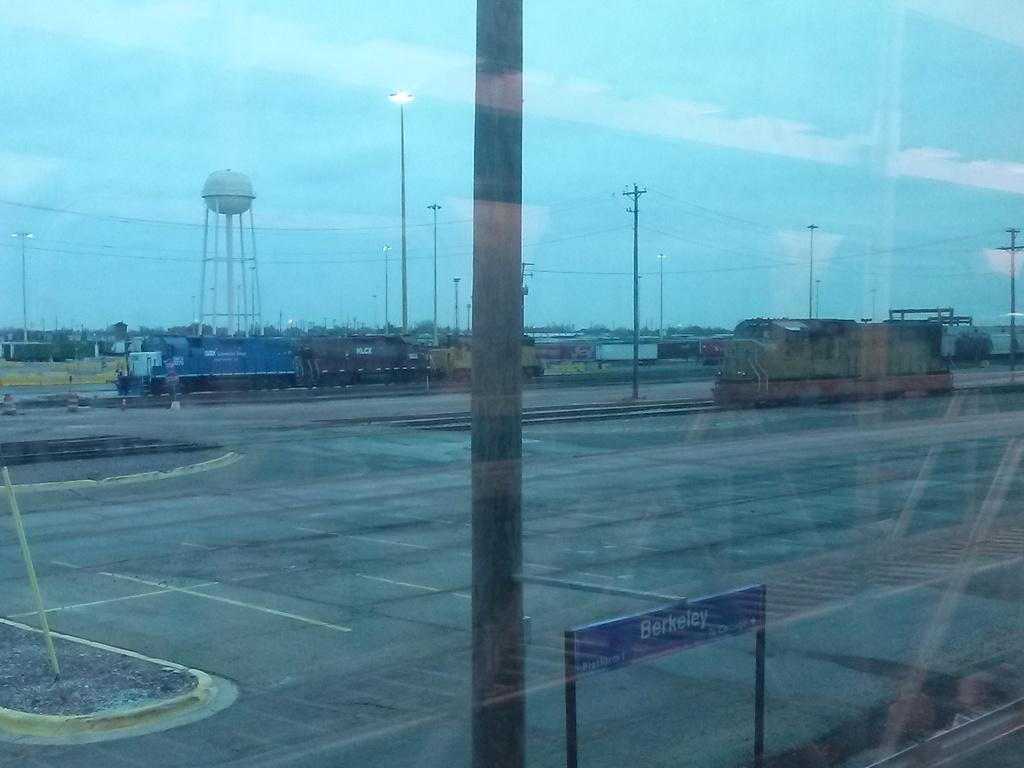<image>
Describe the image concisely. Several trains outside a station that has a sign with the word Berkeley on it. 